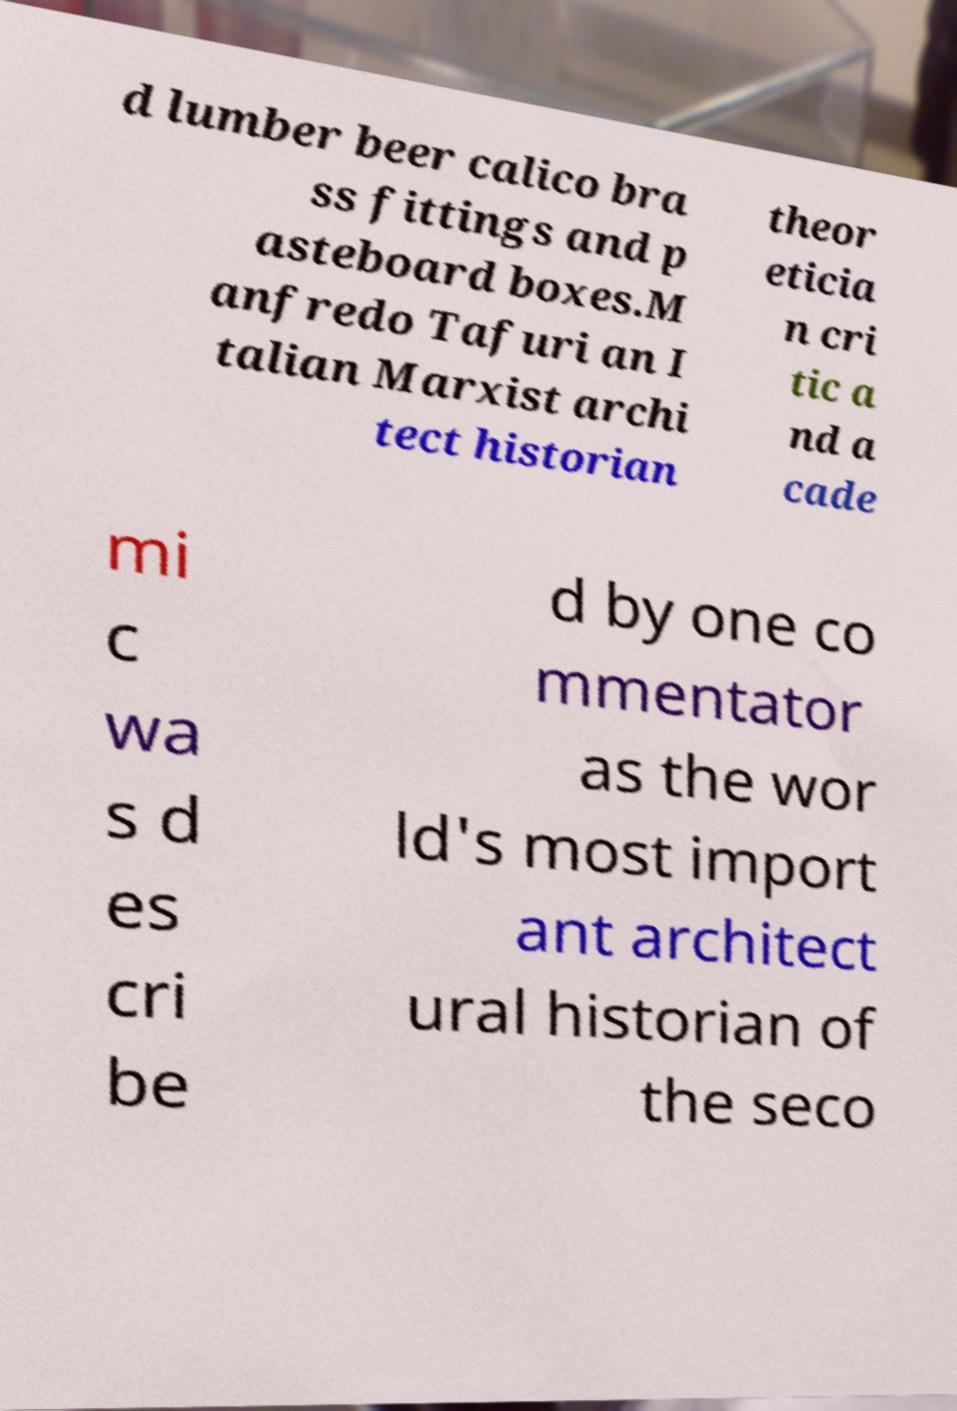Could you extract and type out the text from this image? d lumber beer calico bra ss fittings and p asteboard boxes.M anfredo Tafuri an I talian Marxist archi tect historian theor eticia n cri tic a nd a cade mi c wa s d es cri be d by one co mmentator as the wor ld's most import ant architect ural historian of the seco 